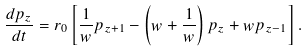<formula> <loc_0><loc_0><loc_500><loc_500>\frac { d p _ { z } } { d t } = r _ { 0 } \left [ \frac { 1 } { w } p _ { z + 1 } - \left ( w + \frac { 1 } { w } \right ) p _ { z } + w p _ { z - 1 } \right ] .</formula> 